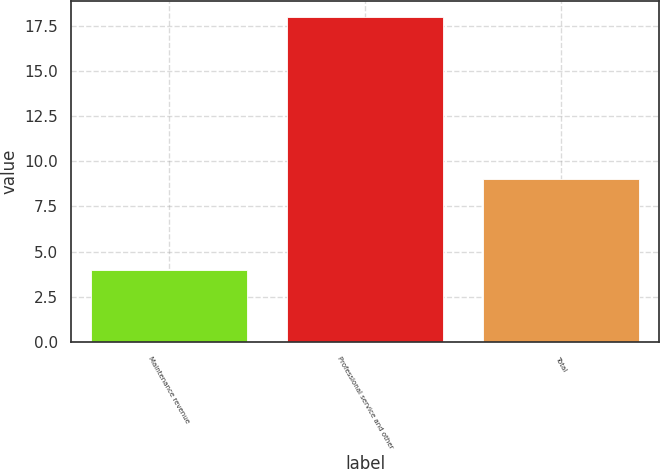Convert chart to OTSL. <chart><loc_0><loc_0><loc_500><loc_500><bar_chart><fcel>Maintenance revenue<fcel>Professional service and other<fcel>Total<nl><fcel>4<fcel>18<fcel>9<nl></chart> 